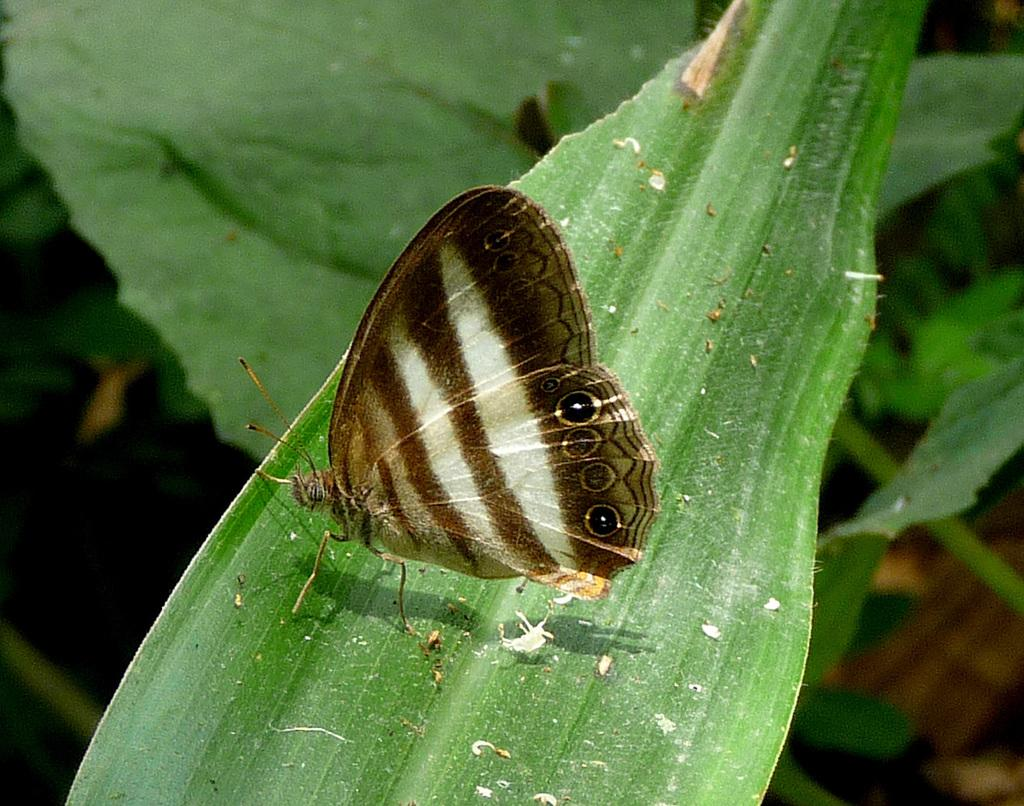What is the main subject in the middle of the image? There is a leaf in the middle of the image. Is there anything on the leaf? Yes, there is a butterfly on the leaf. What can be seen in the background of the image? There are plants in the background of the image. What type of insurance policy is being advertised by the flag in the image? There is no flag present in the image, so it is not possible to determine what type of insurance policy might be advertised. 